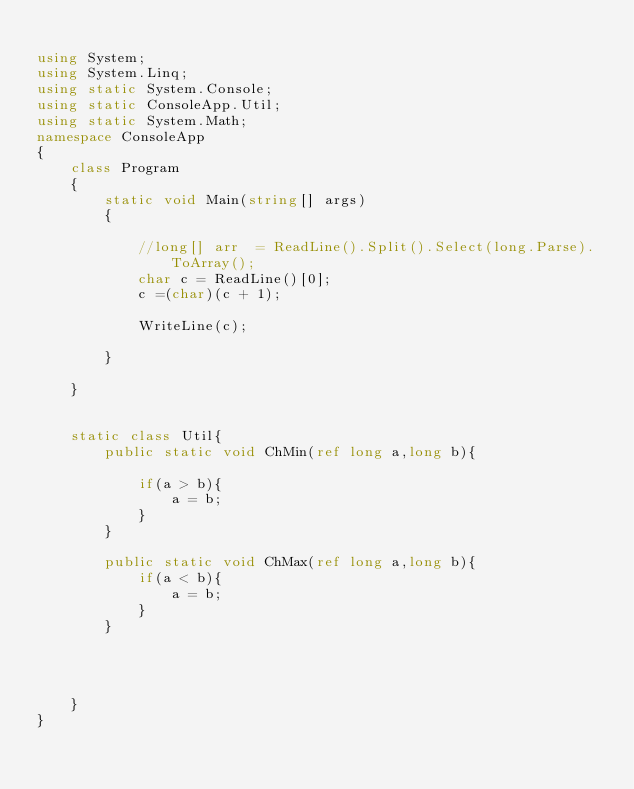<code> <loc_0><loc_0><loc_500><loc_500><_C#_>
using System;
using System.Linq;
using static System.Console;
using static ConsoleApp.Util;
using static System.Math;
namespace ConsoleApp
{
    class Program
    {
        static void Main(string[] args)
        {	

			//long[] arr  = ReadLine().Split().Select(long.Parse).ToArray();
			char c = ReadLine()[0];
			c =(char)(c + 1);

			WriteLine(c);

        }

    }


    static class Util{
        public static void ChMin(ref long a,long b){
            
            if(a > b){
                a = b;
            }
        }

        public static void ChMax(ref long a,long b){
            if(a < b){
                a = b;
            }
        }



		
    }
}

</code> 